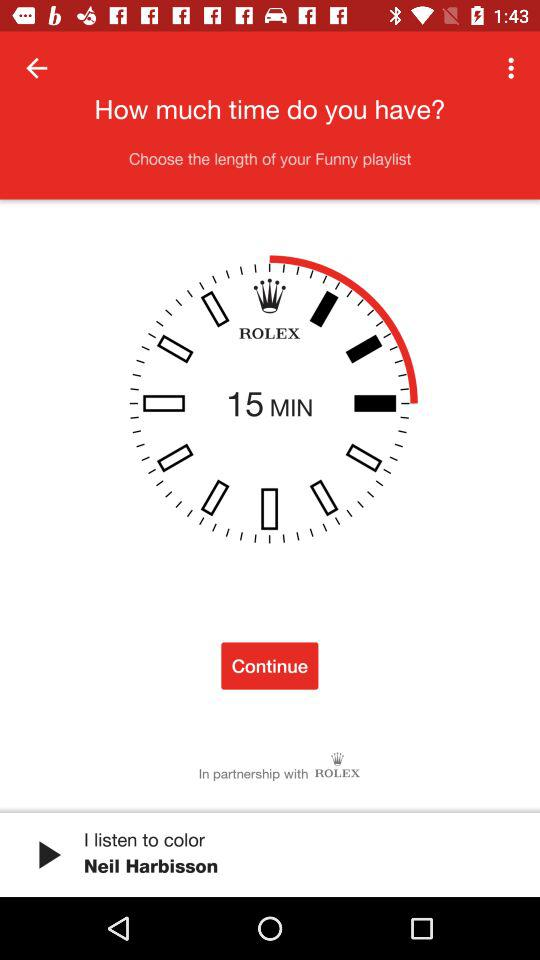What is the duration of "I listen to color"?
When the provided information is insufficient, respond with <no answer>. <no answer> 